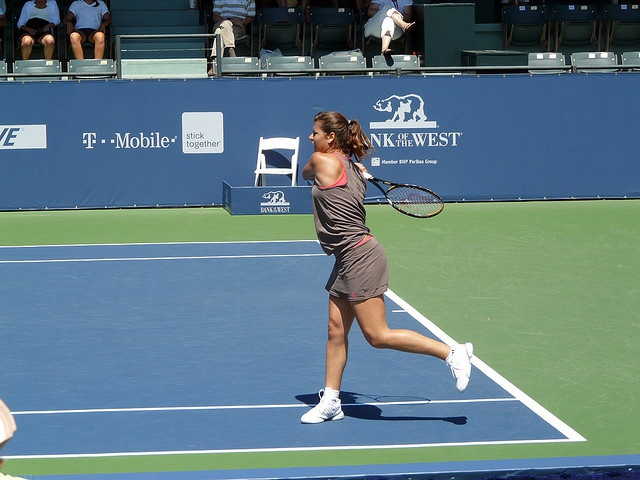Describe the objects in this image and their specific colors. I can see people in blue, black, gray, and white tones, tennis racket in blue, gray, darkgray, and black tones, people in blue, black, gray, and salmon tones, people in blue, black, white, and gray tones, and people in blue, black, gray, and maroon tones in this image. 